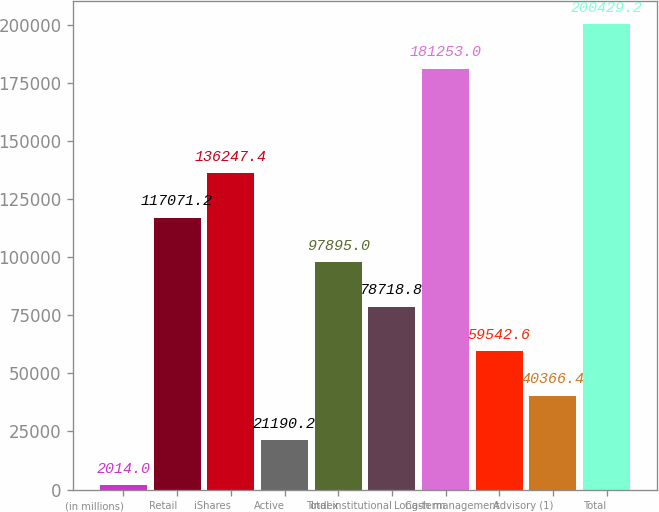Convert chart to OTSL. <chart><loc_0><loc_0><loc_500><loc_500><bar_chart><fcel>(in millions)<fcel>Retail<fcel>iShares<fcel>Active<fcel>Index<fcel>Total institutional<fcel>Long-term<fcel>Cash management<fcel>Advisory (1)<fcel>Total<nl><fcel>2014<fcel>117071<fcel>136247<fcel>21190.2<fcel>97895<fcel>78718.8<fcel>181253<fcel>59542.6<fcel>40366.4<fcel>200429<nl></chart> 